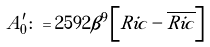Convert formula to latex. <formula><loc_0><loc_0><loc_500><loc_500>A ^ { \prime } _ { 0 } \colon = 2 5 9 2 \beta ^ { 9 } \left [ { R i c } - { \overline { R i c } } \right ]</formula> 